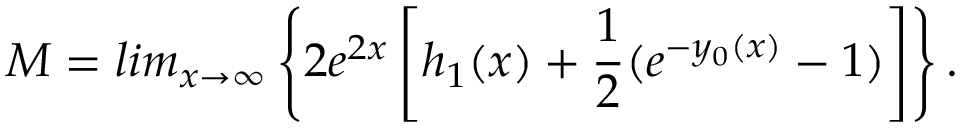Convert formula to latex. <formula><loc_0><loc_0><loc_500><loc_500>M = l i m _ { x \rightarrow \infty } \left \{ 2 e ^ { 2 x } \left [ h _ { 1 } ( x ) + \frac { 1 } { 2 } ( e ^ { - y _ { 0 } ( x ) } - 1 ) \right ] \right \} .</formula> 